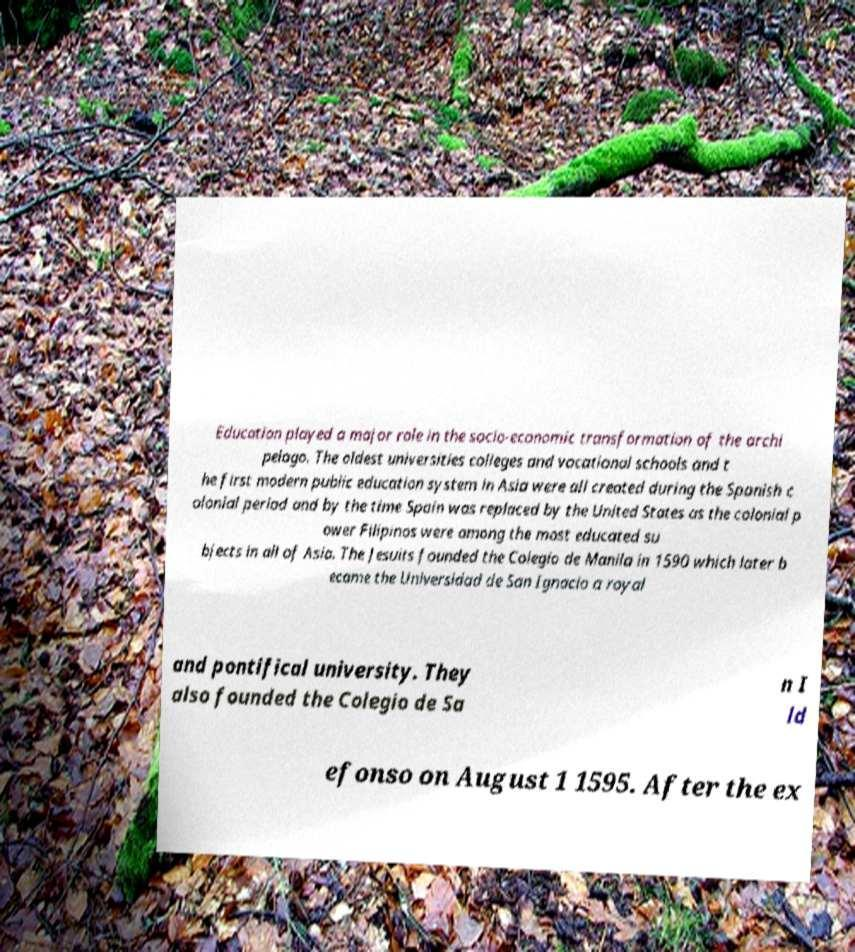Can you read and provide the text displayed in the image?This photo seems to have some interesting text. Can you extract and type it out for me? Education played a major role in the socio-economic transformation of the archi pelago. The oldest universities colleges and vocational schools and t he first modern public education system in Asia were all created during the Spanish c olonial period and by the time Spain was replaced by the United States as the colonial p ower Filipinos were among the most educated su bjects in all of Asia. The Jesuits founded the Colegio de Manila in 1590 which later b ecame the Universidad de San Ignacio a royal and pontifical university. They also founded the Colegio de Sa n I ld efonso on August 1 1595. After the ex 